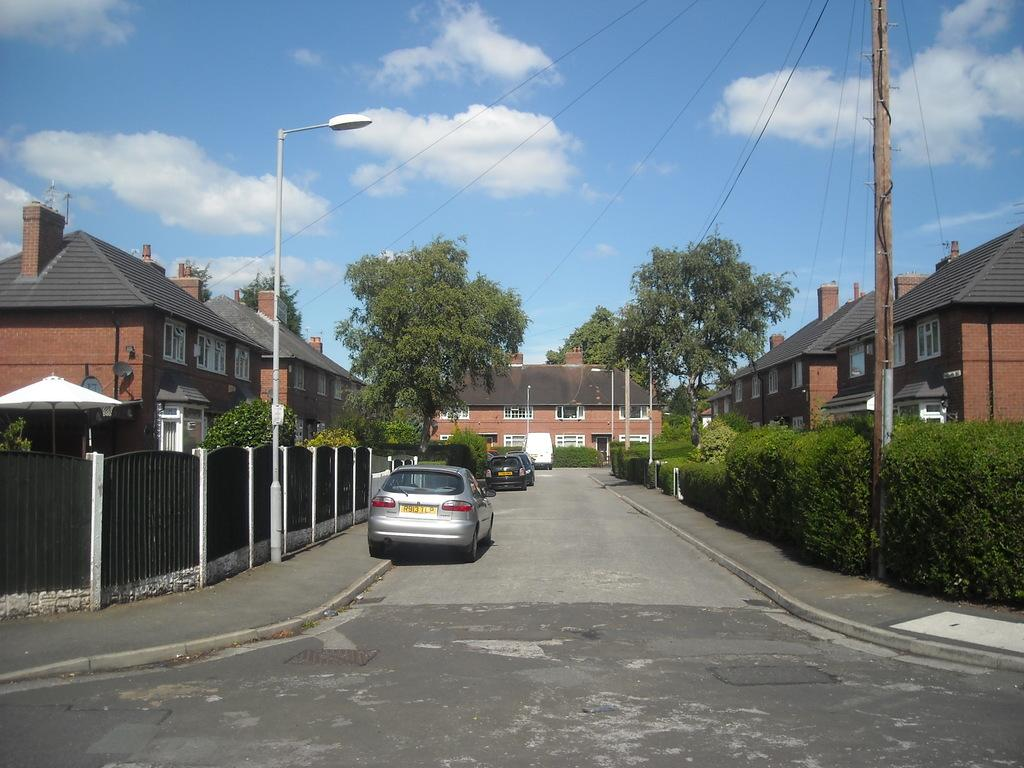What is the main feature of the image? There is a road in the image. What can be seen beside the road? There are cars parked beside the road. What type of vegetation is present in the image? There are plants and trees in the image. What type of buildings can be seen in the image? There are houses in the image. Can you see your friend playing on the seashore in the image? There is no seashore or friend present in the image. Is there any magic happening in the image? There is no magic or any indication of supernatural events in the image. 